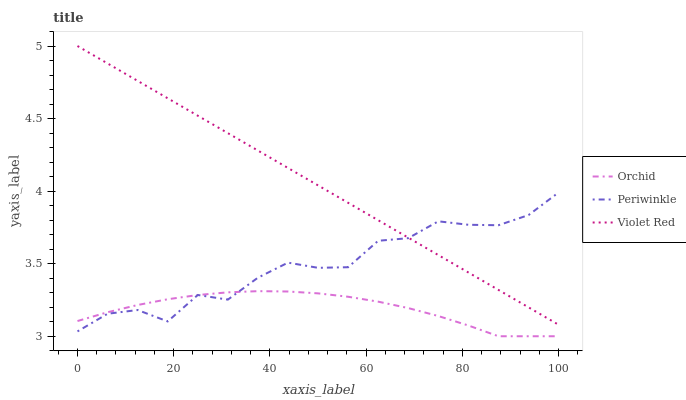Does Orchid have the minimum area under the curve?
Answer yes or no. Yes. Does Violet Red have the maximum area under the curve?
Answer yes or no. Yes. Does Periwinkle have the minimum area under the curve?
Answer yes or no. No. Does Periwinkle have the maximum area under the curve?
Answer yes or no. No. Is Violet Red the smoothest?
Answer yes or no. Yes. Is Periwinkle the roughest?
Answer yes or no. Yes. Is Orchid the smoothest?
Answer yes or no. No. Is Orchid the roughest?
Answer yes or no. No. Does Periwinkle have the lowest value?
Answer yes or no. No. Does Periwinkle have the highest value?
Answer yes or no. No. Is Orchid less than Violet Red?
Answer yes or no. Yes. Is Violet Red greater than Orchid?
Answer yes or no. Yes. Does Orchid intersect Violet Red?
Answer yes or no. No. 